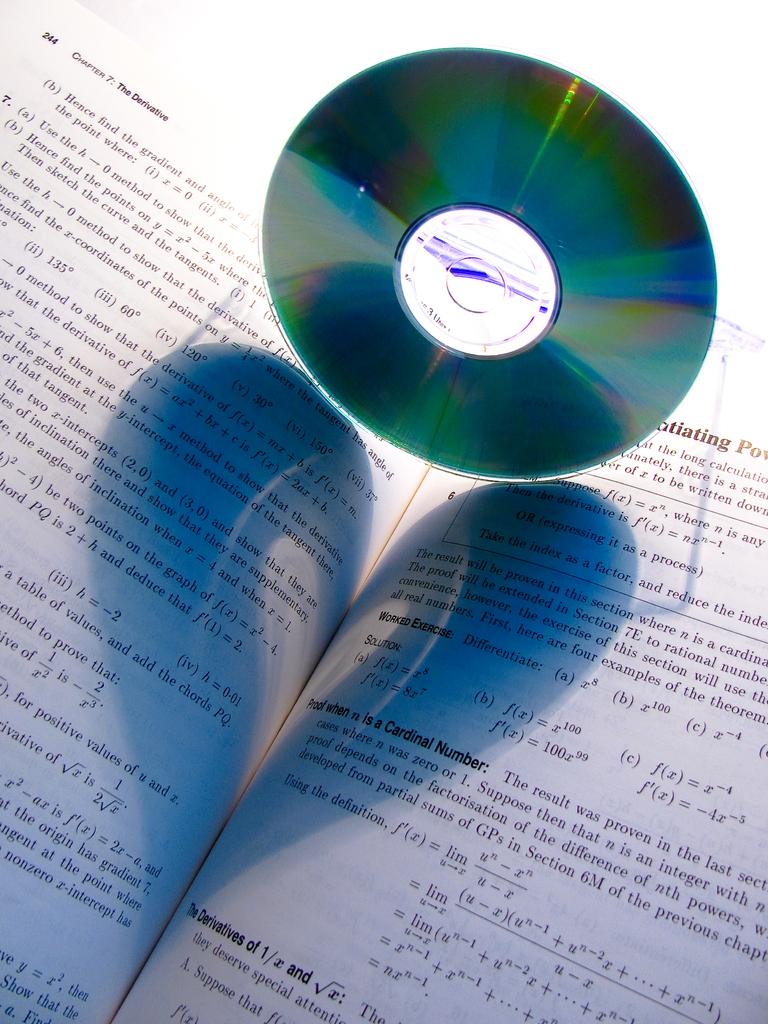What is the word after cardinal?
Offer a terse response. Number. 